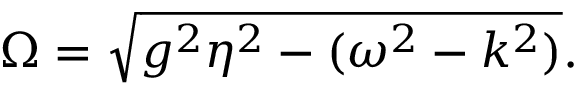<formula> <loc_0><loc_0><loc_500><loc_500>\Omega = \sqrt { g ^ { 2 } \eta ^ { 2 } - ( \omega ^ { 2 } - k ^ { 2 } ) } .</formula> 